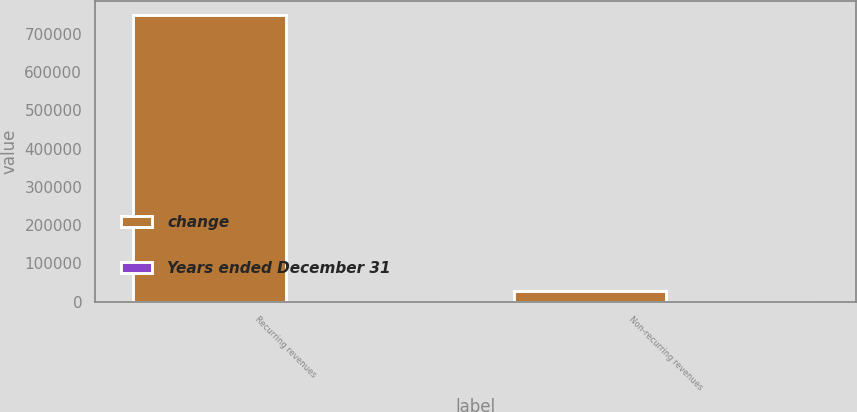Convert chart to OTSL. <chart><loc_0><loc_0><loc_500><loc_500><stacked_bar_chart><ecel><fcel>Recurring revenues<fcel>Non-recurring revenues<nl><fcel>change<fcel>748648<fcel>27527<nl><fcel>Years ended December 31<fcel>45<fcel>40<nl></chart> 